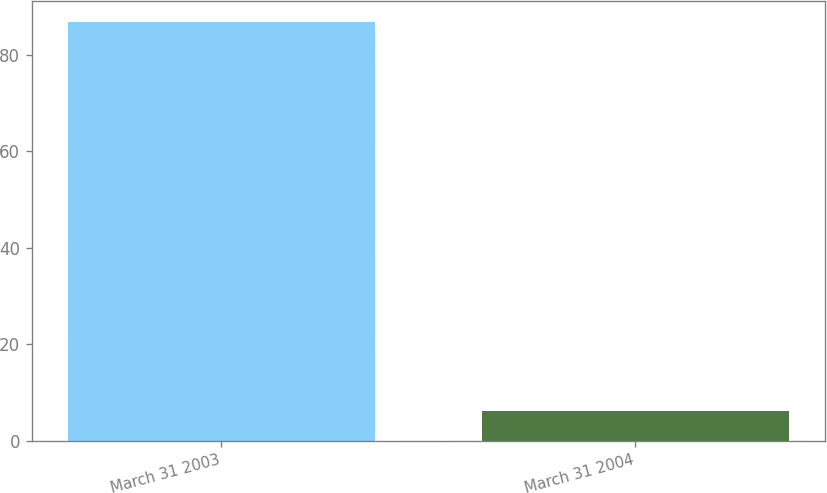Convert chart to OTSL. <chart><loc_0><loc_0><loc_500><loc_500><bar_chart><fcel>March 31 2003<fcel>March 31 2004<nl><fcel>86.9<fcel>6.2<nl></chart> 